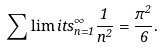Convert formula to latex. <formula><loc_0><loc_0><loc_500><loc_500>\sum \lim i t s _ { n = 1 } ^ { \infty } \frac { 1 } { n ^ { 2 } } = \frac { \pi ^ { 2 } } { 6 } .</formula> 